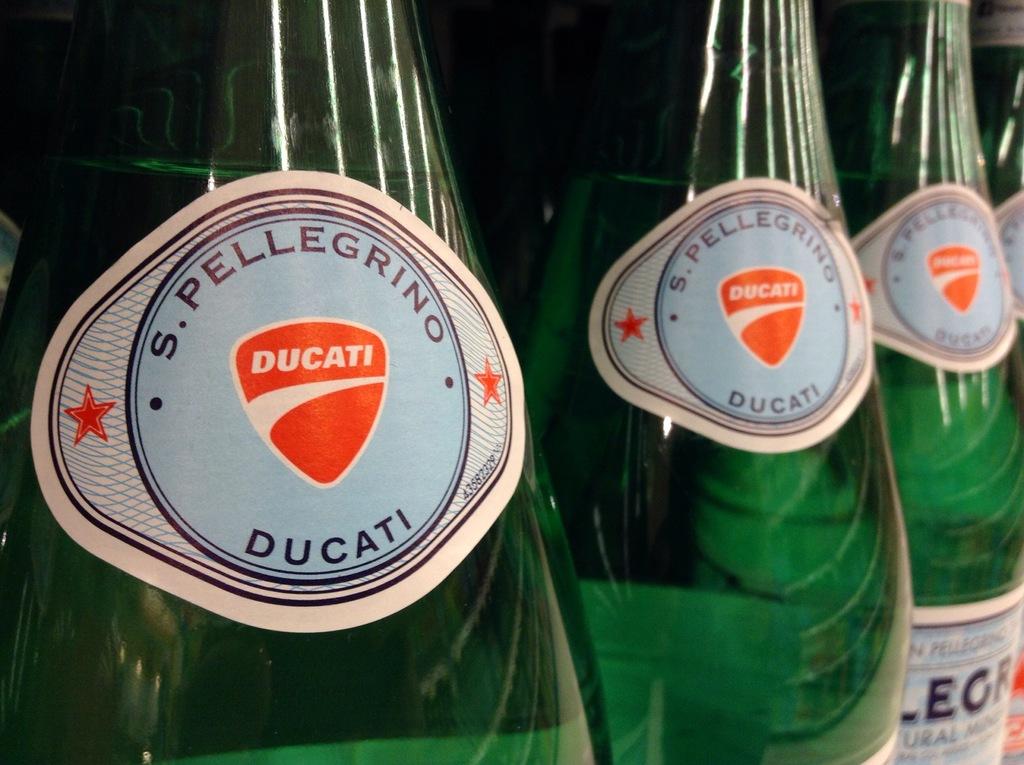What motorcycle company is depicted on the bottle?
Provide a succinct answer. Ducati. 